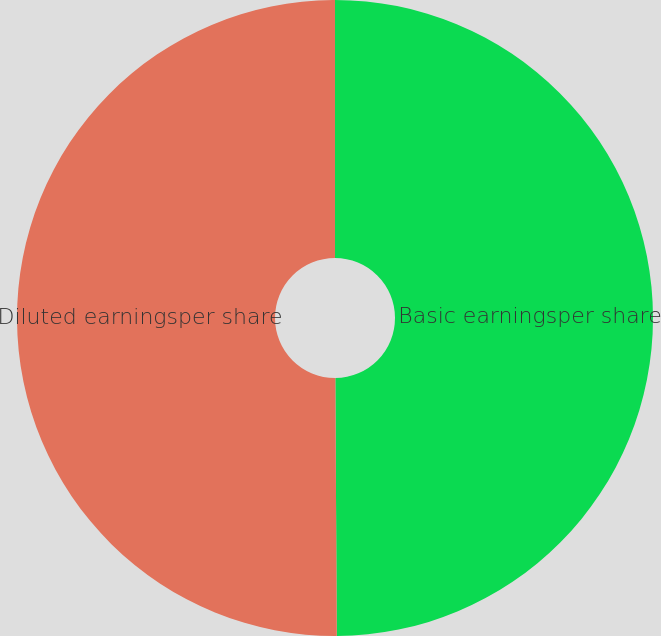Convert chart. <chart><loc_0><loc_0><loc_500><loc_500><pie_chart><fcel>Basic earningsper share<fcel>Diluted earningsper share<nl><fcel>49.91%<fcel>50.09%<nl></chart> 